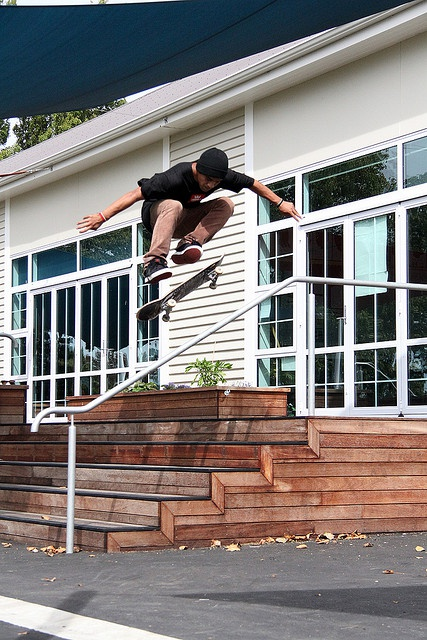Describe the objects in this image and their specific colors. I can see people in olive, black, lightpink, lightgray, and maroon tones and skateboard in olive, black, gray, white, and darkgray tones in this image. 